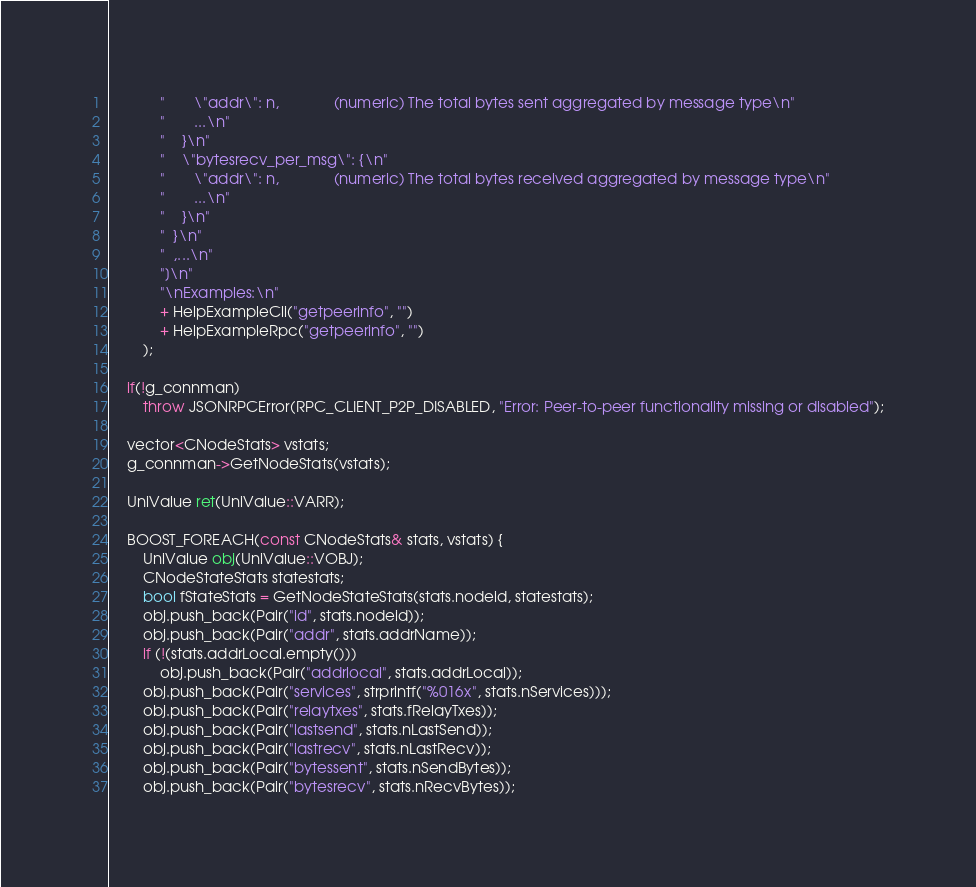<code> <loc_0><loc_0><loc_500><loc_500><_C++_>            "       \"addr\": n,             (numeric) The total bytes sent aggregated by message type\n"
            "       ...\n"
            "    }\n"
            "    \"bytesrecv_per_msg\": {\n"
            "       \"addr\": n,             (numeric) The total bytes received aggregated by message type\n"
            "       ...\n"
            "    }\n"
            "  }\n"
            "  ,...\n"
            "]\n"
            "\nExamples:\n"
            + HelpExampleCli("getpeerinfo", "")
            + HelpExampleRpc("getpeerinfo", "")
        );

    if(!g_connman)
        throw JSONRPCError(RPC_CLIENT_P2P_DISABLED, "Error: Peer-to-peer functionality missing or disabled");

    vector<CNodeStats> vstats;
    g_connman->GetNodeStats(vstats);

    UniValue ret(UniValue::VARR);

    BOOST_FOREACH(const CNodeStats& stats, vstats) {
        UniValue obj(UniValue::VOBJ);
        CNodeStateStats statestats;
        bool fStateStats = GetNodeStateStats(stats.nodeid, statestats);
        obj.push_back(Pair("id", stats.nodeid));
        obj.push_back(Pair("addr", stats.addrName));
        if (!(stats.addrLocal.empty()))
            obj.push_back(Pair("addrlocal", stats.addrLocal));
        obj.push_back(Pair("services", strprintf("%016x", stats.nServices)));
        obj.push_back(Pair("relaytxes", stats.fRelayTxes));
        obj.push_back(Pair("lastsend", stats.nLastSend));
        obj.push_back(Pair("lastrecv", stats.nLastRecv));
        obj.push_back(Pair("bytessent", stats.nSendBytes));
        obj.push_back(Pair("bytesrecv", stats.nRecvBytes));</code> 